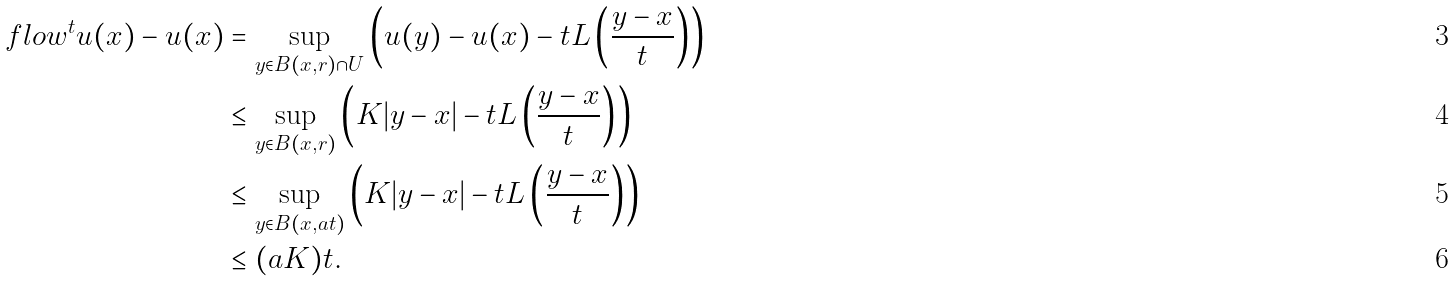Convert formula to latex. <formula><loc_0><loc_0><loc_500><loc_500>\ f l o w ^ { t } u ( x ) - u ( x ) & = \sup _ { y \in B ( x , r ) \cap U } \left ( u ( y ) - u ( x ) - t L \left ( \frac { y - x } { t } \right ) \right ) \\ & \leq \sup _ { y \in B ( x , r ) } \left ( K | y - x | - t L \left ( \frac { y - x } { t } \right ) \right ) \\ & \leq \sup _ { y \in B ( x , a t ) } \left ( K | y - x | - t L \left ( \frac { y - x } { t } \right ) \right ) \\ & \leq ( a K ) t .</formula> 